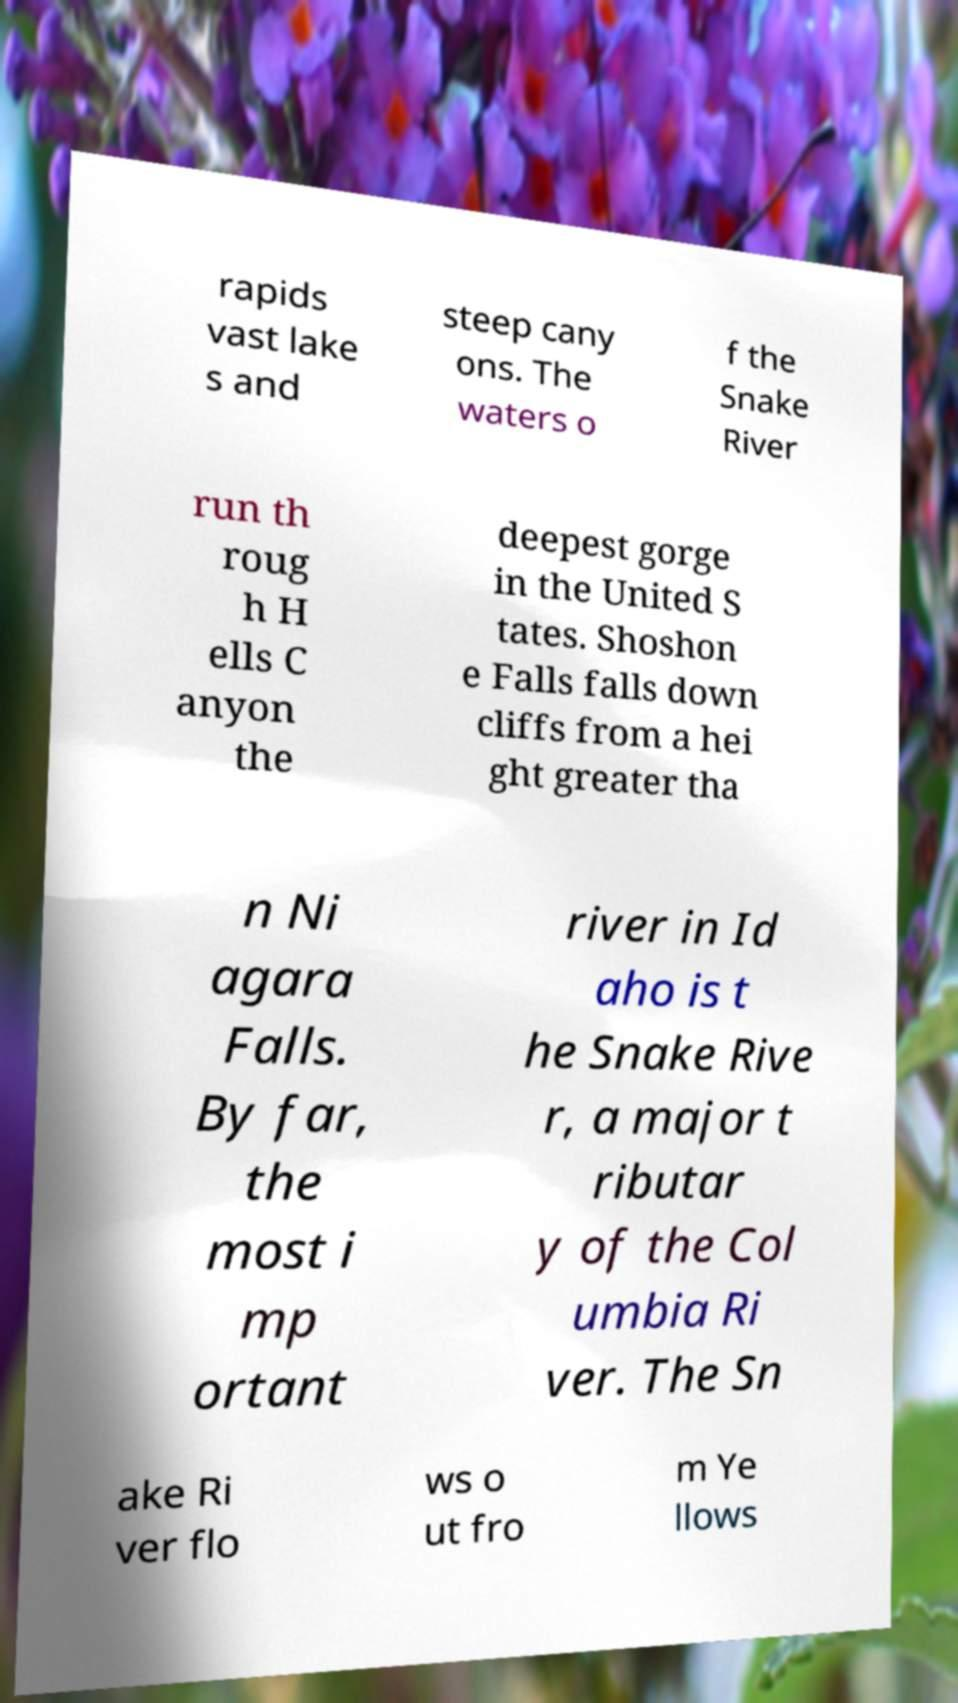Can you read and provide the text displayed in the image?This photo seems to have some interesting text. Can you extract and type it out for me? rapids vast lake s and steep cany ons. The waters o f the Snake River run th roug h H ells C anyon the deepest gorge in the United S tates. Shoshon e Falls falls down cliffs from a hei ght greater tha n Ni agara Falls. By far, the most i mp ortant river in Id aho is t he Snake Rive r, a major t ributar y of the Col umbia Ri ver. The Sn ake Ri ver flo ws o ut fro m Ye llows 